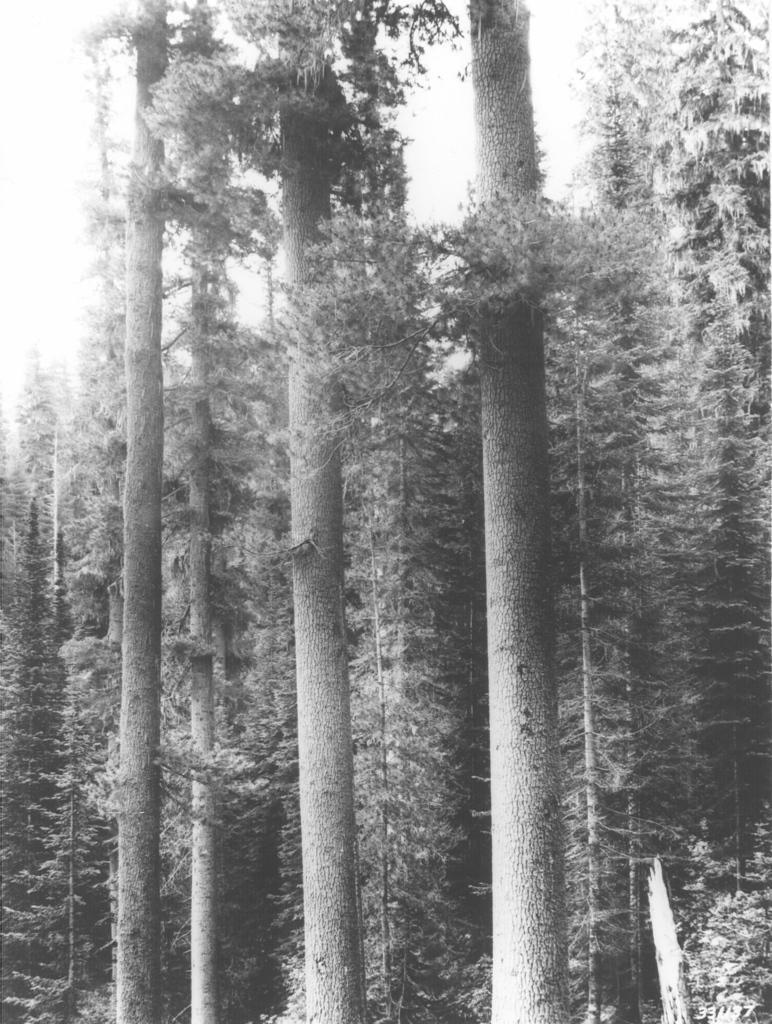What is the primary feature of the image? There are many trees in the image. Can you describe the landscape in the image? The landscape is dominated by trees. Are there any other natural elements visible in the image? The facts provided do not mention any other natural elements besides trees. Where is the lake located in the image? There is no lake present in the image; it only features trees. What type of cord is hanging from the branches of the trees in the image? There is no cord visible in the image; it only features trees. 